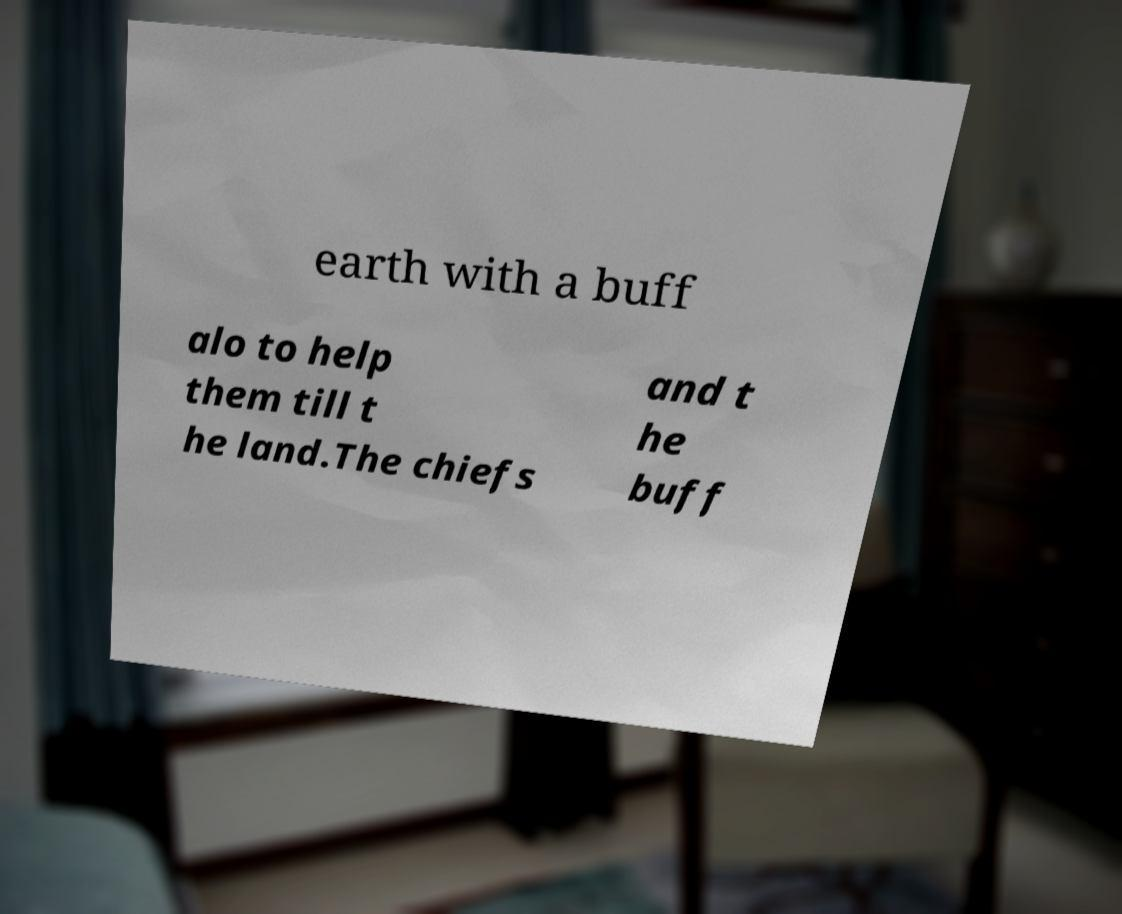For documentation purposes, I need the text within this image transcribed. Could you provide that? earth with a buff alo to help them till t he land.The chiefs and t he buff 